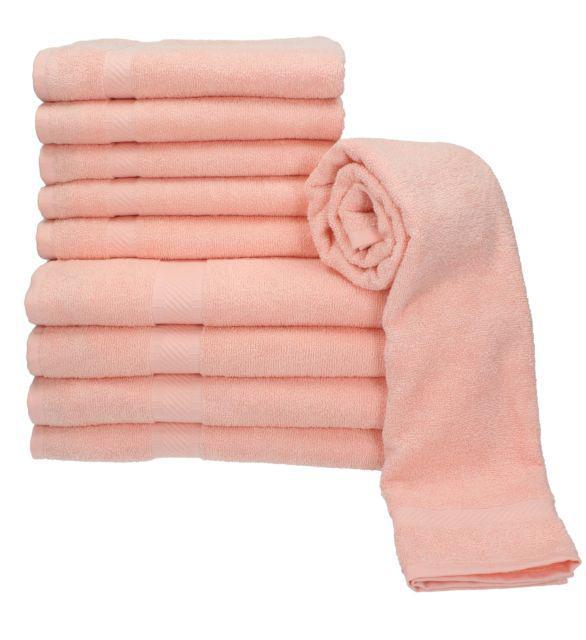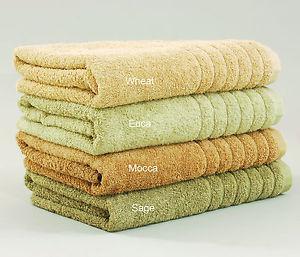The first image is the image on the left, the second image is the image on the right. Given the left and right images, does the statement "The stack of towels in one of the pictures is made up of only identical sized towels." hold true? Answer yes or no. Yes. The first image is the image on the left, the second image is the image on the right. For the images shown, is this caption "There is a stack of all pink towels in one image." true? Answer yes or no. Yes. 